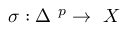Convert formula to latex. <formula><loc_0><loc_0><loc_500><loc_500>\sigma \colon \Delta \ ^ { p } \rightarrow \ X</formula> 